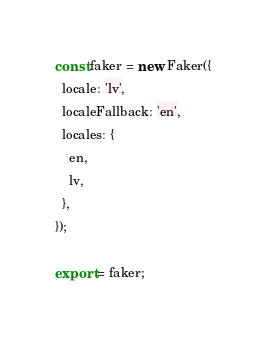Convert code to text. <code><loc_0><loc_0><loc_500><loc_500><_TypeScript_>const faker = new Faker({
  locale: 'lv',
  localeFallback: 'en',
  locales: {
    en,
    lv,
  },
});

export = faker;
</code> 